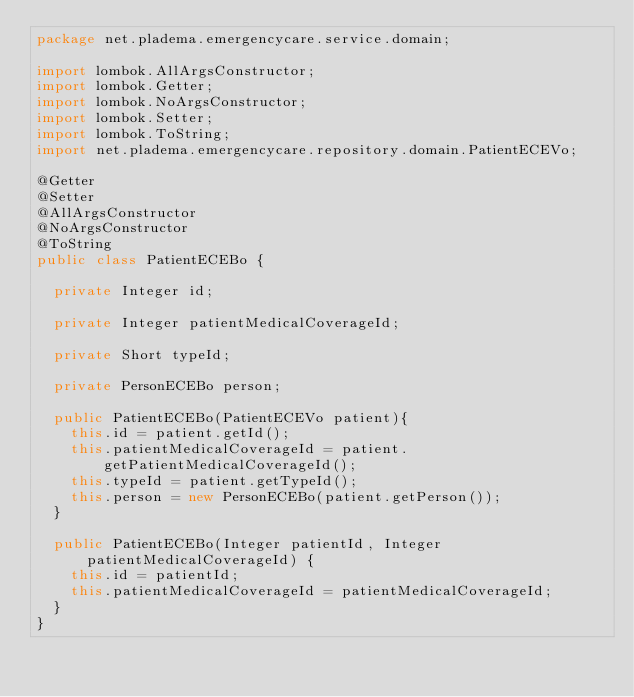Convert code to text. <code><loc_0><loc_0><loc_500><loc_500><_Java_>package net.pladema.emergencycare.service.domain;

import lombok.AllArgsConstructor;
import lombok.Getter;
import lombok.NoArgsConstructor;
import lombok.Setter;
import lombok.ToString;
import net.pladema.emergencycare.repository.domain.PatientECEVo;

@Getter
@Setter
@AllArgsConstructor
@NoArgsConstructor
@ToString
public class PatientECEBo {

	private Integer id;

	private Integer patientMedicalCoverageId;

	private Short typeId;

	private PersonECEBo person;

	public PatientECEBo(PatientECEVo patient){
		this.id = patient.getId();
		this.patientMedicalCoverageId = patient.getPatientMedicalCoverageId();
		this.typeId = patient.getTypeId();
		this.person = new PersonECEBo(patient.getPerson());
	}

	public PatientECEBo(Integer patientId, Integer patientMedicalCoverageId) {
		this.id = patientId;
		this.patientMedicalCoverageId = patientMedicalCoverageId;
	}
}
</code> 